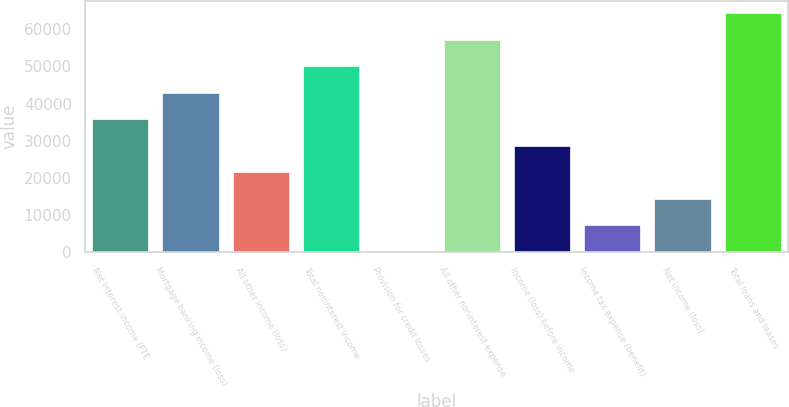Convert chart to OTSL. <chart><loc_0><loc_0><loc_500><loc_500><bar_chart><fcel>Net interest income (FTE<fcel>Mortgage banking income (loss)<fcel>All other income (loss)<fcel>Total noninterest income<fcel>Provision for credit losses<fcel>All other noninterest expense<fcel>Income (loss) before income<fcel>Income tax expense (benefit)<fcel>Net income (loss)<fcel>Total loans and leases<nl><fcel>35870.5<fcel>42998<fcel>21615.5<fcel>50125.5<fcel>233<fcel>57253<fcel>28743<fcel>7360.5<fcel>14488<fcel>64380.5<nl></chart> 